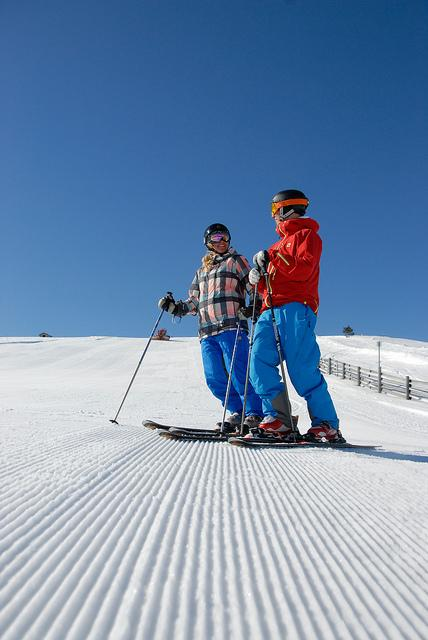Why are they so close together? Please explain your reasoning. friendly. They're friendly. 